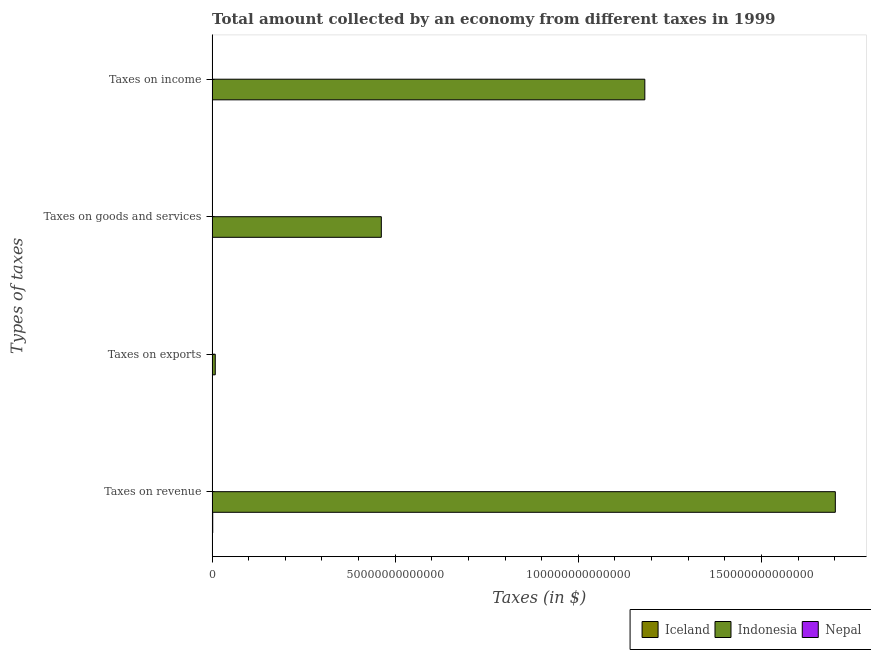How many different coloured bars are there?
Provide a succinct answer. 3. How many groups of bars are there?
Give a very brief answer. 4. Are the number of bars on each tick of the Y-axis equal?
Your response must be concise. No. How many bars are there on the 1st tick from the top?
Keep it short and to the point. 3. What is the label of the 2nd group of bars from the top?
Your response must be concise. Taxes on goods and services. What is the amount collected as tax on goods in Nepal?
Keep it short and to the point. 1.20e+1. Across all countries, what is the maximum amount collected as tax on revenue?
Your answer should be very brief. 1.70e+14. Across all countries, what is the minimum amount collected as tax on goods?
Keep it short and to the point. 1.20e+1. In which country was the amount collected as tax on exports maximum?
Provide a short and direct response. Indonesia. What is the total amount collected as tax on goods in the graph?
Offer a very short reply. 4.63e+13. What is the difference between the amount collected as tax on income in Nepal and that in Iceland?
Keep it short and to the point. -4.60e+1. What is the difference between the amount collected as tax on revenue in Indonesia and the amount collected as tax on goods in Nepal?
Ensure brevity in your answer.  1.70e+14. What is the average amount collected as tax on income per country?
Keep it short and to the point. 3.94e+13. What is the difference between the amount collected as tax on revenue and amount collected as tax on goods in Iceland?
Offer a very short reply. 6.32e+1. What is the ratio of the amount collected as tax on income in Indonesia to that in Iceland?
Ensure brevity in your answer.  2281.18. Is the amount collected as tax on goods in Nepal less than that in Indonesia?
Your response must be concise. Yes. Is the difference between the amount collected as tax on income in Nepal and Indonesia greater than the difference between the amount collected as tax on exports in Nepal and Indonesia?
Make the answer very short. No. What is the difference between the highest and the second highest amount collected as tax on revenue?
Your answer should be very brief. 1.70e+14. What is the difference between the highest and the lowest amount collected as tax on income?
Provide a short and direct response. 1.18e+14. In how many countries, is the amount collected as tax on exports greater than the average amount collected as tax on exports taken over all countries?
Your response must be concise. 1. Is it the case that in every country, the sum of the amount collected as tax on income and amount collected as tax on goods is greater than the sum of amount collected as tax on exports and amount collected as tax on revenue?
Offer a terse response. No. Are all the bars in the graph horizontal?
Your response must be concise. Yes. How many countries are there in the graph?
Your response must be concise. 3. What is the difference between two consecutive major ticks on the X-axis?
Your answer should be very brief. 5.00e+13. Does the graph contain any zero values?
Offer a terse response. Yes. Where does the legend appear in the graph?
Offer a very short reply. Bottom right. How are the legend labels stacked?
Make the answer very short. Horizontal. What is the title of the graph?
Your response must be concise. Total amount collected by an economy from different taxes in 1999. Does "Central Europe" appear as one of the legend labels in the graph?
Provide a short and direct response. No. What is the label or title of the X-axis?
Offer a very short reply. Taxes (in $). What is the label or title of the Y-axis?
Provide a succinct answer. Types of taxes. What is the Taxes (in $) in Iceland in Taxes on revenue?
Your answer should be compact. 1.68e+11. What is the Taxes (in $) of Indonesia in Taxes on revenue?
Offer a very short reply. 1.70e+14. What is the Taxes (in $) in Nepal in Taxes on revenue?
Your answer should be very brief. 2.88e+1. What is the Taxes (in $) of Indonesia in Taxes on exports?
Keep it short and to the point. 8.58e+11. What is the Taxes (in $) in Nepal in Taxes on exports?
Provide a short and direct response. 3.78e+08. What is the Taxes (in $) of Iceland in Taxes on goods and services?
Provide a succinct answer. 1.05e+11. What is the Taxes (in $) of Indonesia in Taxes on goods and services?
Offer a terse response. 4.62e+13. What is the Taxes (in $) of Nepal in Taxes on goods and services?
Make the answer very short. 1.20e+1. What is the Taxes (in $) in Iceland in Taxes on income?
Your response must be concise. 5.18e+1. What is the Taxes (in $) of Indonesia in Taxes on income?
Offer a terse response. 1.18e+14. What is the Taxes (in $) in Nepal in Taxes on income?
Make the answer very short. 5.77e+09. Across all Types of taxes, what is the maximum Taxes (in $) of Iceland?
Provide a short and direct response. 1.68e+11. Across all Types of taxes, what is the maximum Taxes (in $) of Indonesia?
Offer a terse response. 1.70e+14. Across all Types of taxes, what is the maximum Taxes (in $) of Nepal?
Provide a succinct answer. 2.88e+1. Across all Types of taxes, what is the minimum Taxes (in $) of Iceland?
Provide a succinct answer. 0. Across all Types of taxes, what is the minimum Taxes (in $) of Indonesia?
Offer a very short reply. 8.58e+11. Across all Types of taxes, what is the minimum Taxes (in $) of Nepal?
Ensure brevity in your answer.  3.78e+08. What is the total Taxes (in $) in Iceland in the graph?
Ensure brevity in your answer.  3.25e+11. What is the total Taxes (in $) of Indonesia in the graph?
Ensure brevity in your answer.  3.35e+14. What is the total Taxes (in $) of Nepal in the graph?
Provide a succinct answer. 4.70e+1. What is the difference between the Taxes (in $) of Indonesia in Taxes on revenue and that in Taxes on exports?
Your response must be concise. 1.69e+14. What is the difference between the Taxes (in $) of Nepal in Taxes on revenue and that in Taxes on exports?
Offer a very short reply. 2.84e+1. What is the difference between the Taxes (in $) of Iceland in Taxes on revenue and that in Taxes on goods and services?
Offer a very short reply. 6.32e+1. What is the difference between the Taxes (in $) in Indonesia in Taxes on revenue and that in Taxes on goods and services?
Provide a short and direct response. 1.24e+14. What is the difference between the Taxes (in $) of Nepal in Taxes on revenue and that in Taxes on goods and services?
Offer a terse response. 1.68e+1. What is the difference between the Taxes (in $) of Iceland in Taxes on revenue and that in Taxes on income?
Keep it short and to the point. 1.16e+11. What is the difference between the Taxes (in $) of Indonesia in Taxes on revenue and that in Taxes on income?
Keep it short and to the point. 5.20e+13. What is the difference between the Taxes (in $) in Nepal in Taxes on revenue and that in Taxes on income?
Make the answer very short. 2.30e+1. What is the difference between the Taxes (in $) in Indonesia in Taxes on exports and that in Taxes on goods and services?
Your answer should be very brief. -4.53e+13. What is the difference between the Taxes (in $) of Nepal in Taxes on exports and that in Taxes on goods and services?
Your answer should be very brief. -1.16e+1. What is the difference between the Taxes (in $) in Indonesia in Taxes on exports and that in Taxes on income?
Your answer should be compact. -1.17e+14. What is the difference between the Taxes (in $) of Nepal in Taxes on exports and that in Taxes on income?
Keep it short and to the point. -5.40e+09. What is the difference between the Taxes (in $) of Iceland in Taxes on goods and services and that in Taxes on income?
Offer a very short reply. 5.30e+1. What is the difference between the Taxes (in $) of Indonesia in Taxes on goods and services and that in Taxes on income?
Your answer should be compact. -7.20e+13. What is the difference between the Taxes (in $) in Nepal in Taxes on goods and services and that in Taxes on income?
Your answer should be very brief. 6.22e+09. What is the difference between the Taxes (in $) in Iceland in Taxes on revenue and the Taxes (in $) in Indonesia in Taxes on exports?
Give a very brief answer. -6.90e+11. What is the difference between the Taxes (in $) in Iceland in Taxes on revenue and the Taxes (in $) in Nepal in Taxes on exports?
Make the answer very short. 1.68e+11. What is the difference between the Taxes (in $) of Indonesia in Taxes on revenue and the Taxes (in $) of Nepal in Taxes on exports?
Provide a short and direct response. 1.70e+14. What is the difference between the Taxes (in $) in Iceland in Taxes on revenue and the Taxes (in $) in Indonesia in Taxes on goods and services?
Ensure brevity in your answer.  -4.60e+13. What is the difference between the Taxes (in $) of Iceland in Taxes on revenue and the Taxes (in $) of Nepal in Taxes on goods and services?
Provide a succinct answer. 1.56e+11. What is the difference between the Taxes (in $) of Indonesia in Taxes on revenue and the Taxes (in $) of Nepal in Taxes on goods and services?
Give a very brief answer. 1.70e+14. What is the difference between the Taxes (in $) of Iceland in Taxes on revenue and the Taxes (in $) of Indonesia in Taxes on income?
Your response must be concise. -1.18e+14. What is the difference between the Taxes (in $) of Iceland in Taxes on revenue and the Taxes (in $) of Nepal in Taxes on income?
Your answer should be compact. 1.62e+11. What is the difference between the Taxes (in $) in Indonesia in Taxes on revenue and the Taxes (in $) in Nepal in Taxes on income?
Provide a succinct answer. 1.70e+14. What is the difference between the Taxes (in $) of Indonesia in Taxes on exports and the Taxes (in $) of Nepal in Taxes on goods and services?
Your response must be concise. 8.46e+11. What is the difference between the Taxes (in $) of Indonesia in Taxes on exports and the Taxes (in $) of Nepal in Taxes on income?
Provide a succinct answer. 8.52e+11. What is the difference between the Taxes (in $) of Iceland in Taxes on goods and services and the Taxes (in $) of Indonesia in Taxes on income?
Provide a succinct answer. -1.18e+14. What is the difference between the Taxes (in $) of Iceland in Taxes on goods and services and the Taxes (in $) of Nepal in Taxes on income?
Provide a succinct answer. 9.90e+1. What is the difference between the Taxes (in $) of Indonesia in Taxes on goods and services and the Taxes (in $) of Nepal in Taxes on income?
Make the answer very short. 4.62e+13. What is the average Taxes (in $) of Iceland per Types of taxes?
Your answer should be compact. 8.12e+1. What is the average Taxes (in $) of Indonesia per Types of taxes?
Offer a terse response. 8.39e+13. What is the average Taxes (in $) of Nepal per Types of taxes?
Provide a short and direct response. 1.17e+1. What is the difference between the Taxes (in $) of Iceland and Taxes (in $) of Indonesia in Taxes on revenue?
Keep it short and to the point. -1.70e+14. What is the difference between the Taxes (in $) in Iceland and Taxes (in $) in Nepal in Taxes on revenue?
Provide a short and direct response. 1.39e+11. What is the difference between the Taxes (in $) in Indonesia and Taxes (in $) in Nepal in Taxes on revenue?
Your answer should be very brief. 1.70e+14. What is the difference between the Taxes (in $) in Indonesia and Taxes (in $) in Nepal in Taxes on exports?
Ensure brevity in your answer.  8.58e+11. What is the difference between the Taxes (in $) of Iceland and Taxes (in $) of Indonesia in Taxes on goods and services?
Offer a very short reply. -4.61e+13. What is the difference between the Taxes (in $) of Iceland and Taxes (in $) of Nepal in Taxes on goods and services?
Keep it short and to the point. 9.28e+1. What is the difference between the Taxes (in $) in Indonesia and Taxes (in $) in Nepal in Taxes on goods and services?
Provide a succinct answer. 4.62e+13. What is the difference between the Taxes (in $) of Iceland and Taxes (in $) of Indonesia in Taxes on income?
Your answer should be very brief. -1.18e+14. What is the difference between the Taxes (in $) of Iceland and Taxes (in $) of Nepal in Taxes on income?
Provide a succinct answer. 4.60e+1. What is the difference between the Taxes (in $) of Indonesia and Taxes (in $) of Nepal in Taxes on income?
Make the answer very short. 1.18e+14. What is the ratio of the Taxes (in $) in Indonesia in Taxes on revenue to that in Taxes on exports?
Make the answer very short. 198.35. What is the ratio of the Taxes (in $) of Nepal in Taxes on revenue to that in Taxes on exports?
Give a very brief answer. 76.21. What is the ratio of the Taxes (in $) in Iceland in Taxes on revenue to that in Taxes on goods and services?
Provide a succinct answer. 1.6. What is the ratio of the Taxes (in $) of Indonesia in Taxes on revenue to that in Taxes on goods and services?
Your response must be concise. 3.68. What is the ratio of the Taxes (in $) of Nepal in Taxes on revenue to that in Taxes on goods and services?
Offer a very short reply. 2.4. What is the ratio of the Taxes (in $) in Iceland in Taxes on revenue to that in Taxes on income?
Offer a terse response. 3.24. What is the ratio of the Taxes (in $) in Indonesia in Taxes on revenue to that in Taxes on income?
Keep it short and to the point. 1.44. What is the ratio of the Taxes (in $) in Nepal in Taxes on revenue to that in Taxes on income?
Offer a terse response. 4.99. What is the ratio of the Taxes (in $) of Indonesia in Taxes on exports to that in Taxes on goods and services?
Provide a short and direct response. 0.02. What is the ratio of the Taxes (in $) in Nepal in Taxes on exports to that in Taxes on goods and services?
Make the answer very short. 0.03. What is the ratio of the Taxes (in $) of Indonesia in Taxes on exports to that in Taxes on income?
Provide a succinct answer. 0.01. What is the ratio of the Taxes (in $) of Nepal in Taxes on exports to that in Taxes on income?
Make the answer very short. 0.07. What is the ratio of the Taxes (in $) in Iceland in Taxes on goods and services to that in Taxes on income?
Your answer should be compact. 2.02. What is the ratio of the Taxes (in $) of Indonesia in Taxes on goods and services to that in Taxes on income?
Your answer should be very brief. 0.39. What is the ratio of the Taxes (in $) of Nepal in Taxes on goods and services to that in Taxes on income?
Your response must be concise. 2.08. What is the difference between the highest and the second highest Taxes (in $) in Iceland?
Provide a succinct answer. 6.32e+1. What is the difference between the highest and the second highest Taxes (in $) of Indonesia?
Keep it short and to the point. 5.20e+13. What is the difference between the highest and the second highest Taxes (in $) in Nepal?
Provide a short and direct response. 1.68e+1. What is the difference between the highest and the lowest Taxes (in $) in Iceland?
Your response must be concise. 1.68e+11. What is the difference between the highest and the lowest Taxes (in $) in Indonesia?
Provide a short and direct response. 1.69e+14. What is the difference between the highest and the lowest Taxes (in $) of Nepal?
Your answer should be compact. 2.84e+1. 